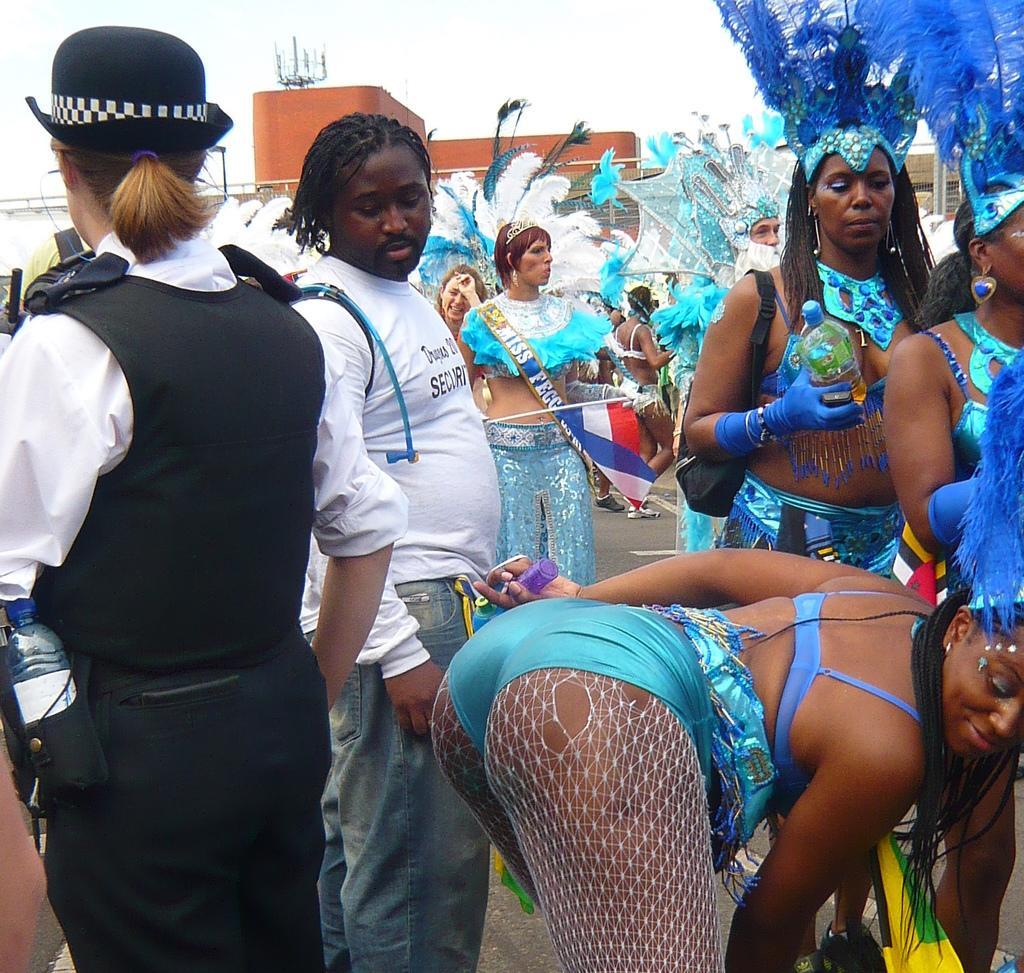How would you summarize this image in a sentence or two? At the bottom of this image, there are persons, one of them is bending and smiling. In the background, there is a building and there are clouds in the sky. 